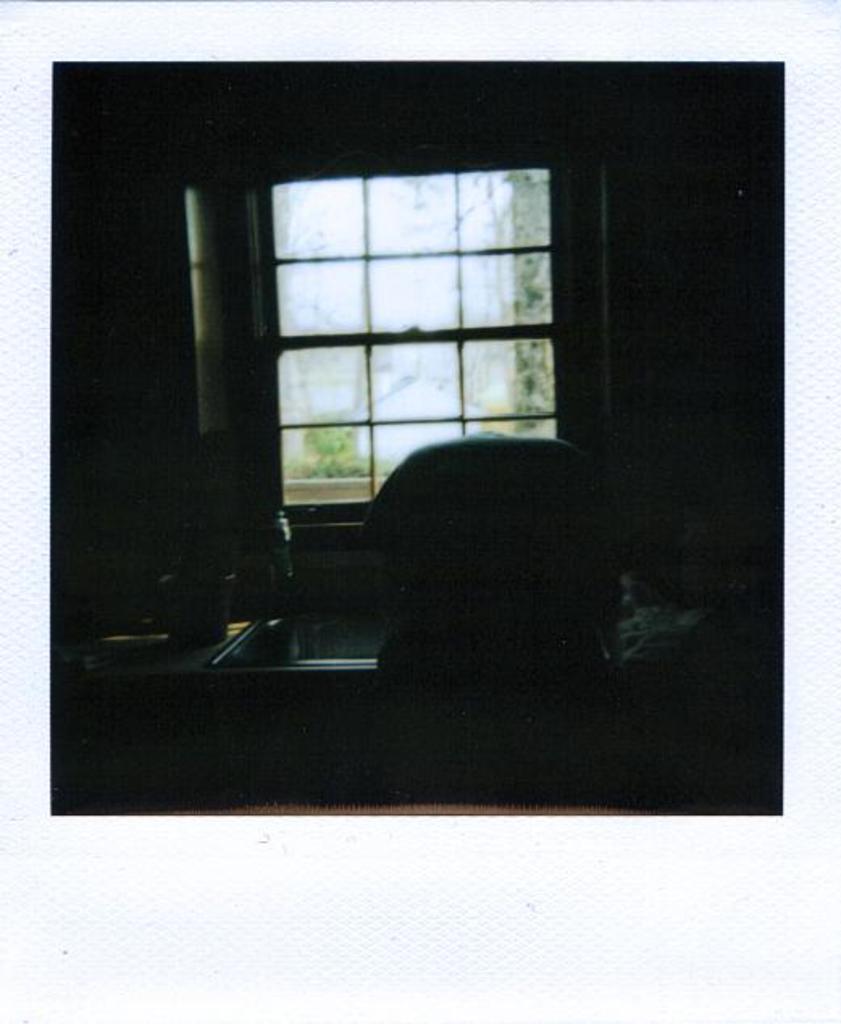Please provide a concise description of this image. In this picture I can see a window and a table. I can also see some other objects in the image. This image is dark. 